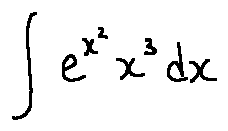<formula> <loc_0><loc_0><loc_500><loc_500>\int e ^ { x ^ { 2 } } x ^ { 3 } d x</formula> 